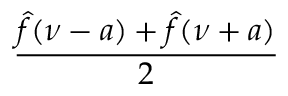<formula> <loc_0><loc_0><loc_500><loc_500>\frac { { \hat { f } } ( \nu - a ) + { \hat { f } } ( \nu + a ) } { 2 }</formula> 